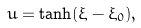Convert formula to latex. <formula><loc_0><loc_0><loc_500><loc_500>u = \tanh ( \xi - \xi _ { 0 } ) ,</formula> 